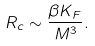Convert formula to latex. <formula><loc_0><loc_0><loc_500><loc_500>R _ { c } \sim \frac { \beta K _ { F } } { M ^ { 3 } } .</formula> 